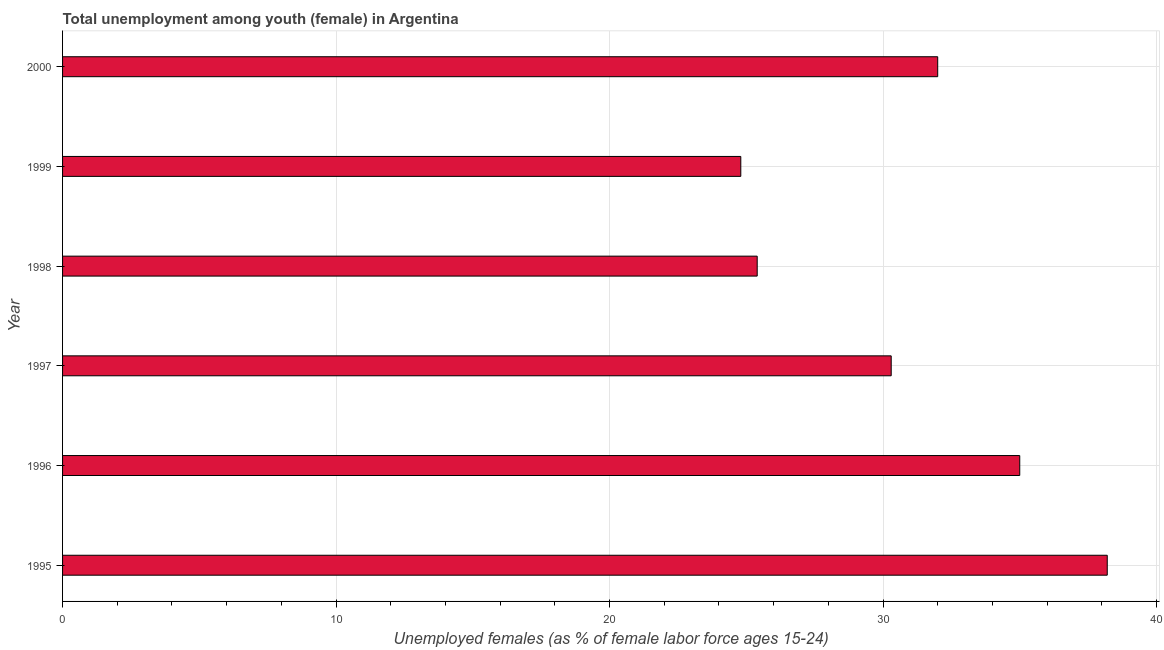Does the graph contain any zero values?
Give a very brief answer. No. What is the title of the graph?
Make the answer very short. Total unemployment among youth (female) in Argentina. What is the label or title of the X-axis?
Keep it short and to the point. Unemployed females (as % of female labor force ages 15-24). What is the unemployed female youth population in 1998?
Provide a succinct answer. 25.4. Across all years, what is the maximum unemployed female youth population?
Your answer should be very brief. 38.2. Across all years, what is the minimum unemployed female youth population?
Your answer should be very brief. 24.8. In which year was the unemployed female youth population maximum?
Offer a terse response. 1995. What is the sum of the unemployed female youth population?
Make the answer very short. 185.7. What is the average unemployed female youth population per year?
Give a very brief answer. 30.95. What is the median unemployed female youth population?
Your answer should be compact. 31.15. What is the ratio of the unemployed female youth population in 1997 to that in 1999?
Your response must be concise. 1.22. Is the unemployed female youth population in 1995 less than that in 1997?
Give a very brief answer. No. In how many years, is the unemployed female youth population greater than the average unemployed female youth population taken over all years?
Ensure brevity in your answer.  3. Are all the bars in the graph horizontal?
Give a very brief answer. Yes. How many years are there in the graph?
Your answer should be compact. 6. What is the difference between two consecutive major ticks on the X-axis?
Provide a succinct answer. 10. What is the Unemployed females (as % of female labor force ages 15-24) of 1995?
Ensure brevity in your answer.  38.2. What is the Unemployed females (as % of female labor force ages 15-24) in 1996?
Keep it short and to the point. 35. What is the Unemployed females (as % of female labor force ages 15-24) of 1997?
Keep it short and to the point. 30.3. What is the Unemployed females (as % of female labor force ages 15-24) in 1998?
Give a very brief answer. 25.4. What is the Unemployed females (as % of female labor force ages 15-24) of 1999?
Offer a terse response. 24.8. What is the difference between the Unemployed females (as % of female labor force ages 15-24) in 1995 and 1999?
Your answer should be compact. 13.4. What is the difference between the Unemployed females (as % of female labor force ages 15-24) in 1995 and 2000?
Keep it short and to the point. 6.2. What is the difference between the Unemployed females (as % of female labor force ages 15-24) in 1996 and 1997?
Your answer should be very brief. 4.7. What is the difference between the Unemployed females (as % of female labor force ages 15-24) in 1996 and 1999?
Offer a terse response. 10.2. What is the difference between the Unemployed females (as % of female labor force ages 15-24) in 1996 and 2000?
Provide a short and direct response. 3. What is the difference between the Unemployed females (as % of female labor force ages 15-24) in 1997 and 1998?
Provide a succinct answer. 4.9. What is the ratio of the Unemployed females (as % of female labor force ages 15-24) in 1995 to that in 1996?
Offer a very short reply. 1.09. What is the ratio of the Unemployed females (as % of female labor force ages 15-24) in 1995 to that in 1997?
Ensure brevity in your answer.  1.26. What is the ratio of the Unemployed females (as % of female labor force ages 15-24) in 1995 to that in 1998?
Offer a very short reply. 1.5. What is the ratio of the Unemployed females (as % of female labor force ages 15-24) in 1995 to that in 1999?
Ensure brevity in your answer.  1.54. What is the ratio of the Unemployed females (as % of female labor force ages 15-24) in 1995 to that in 2000?
Ensure brevity in your answer.  1.19. What is the ratio of the Unemployed females (as % of female labor force ages 15-24) in 1996 to that in 1997?
Provide a succinct answer. 1.16. What is the ratio of the Unemployed females (as % of female labor force ages 15-24) in 1996 to that in 1998?
Offer a very short reply. 1.38. What is the ratio of the Unemployed females (as % of female labor force ages 15-24) in 1996 to that in 1999?
Provide a short and direct response. 1.41. What is the ratio of the Unemployed females (as % of female labor force ages 15-24) in 1996 to that in 2000?
Make the answer very short. 1.09. What is the ratio of the Unemployed females (as % of female labor force ages 15-24) in 1997 to that in 1998?
Provide a short and direct response. 1.19. What is the ratio of the Unemployed females (as % of female labor force ages 15-24) in 1997 to that in 1999?
Offer a very short reply. 1.22. What is the ratio of the Unemployed females (as % of female labor force ages 15-24) in 1997 to that in 2000?
Make the answer very short. 0.95. What is the ratio of the Unemployed females (as % of female labor force ages 15-24) in 1998 to that in 1999?
Provide a succinct answer. 1.02. What is the ratio of the Unemployed females (as % of female labor force ages 15-24) in 1998 to that in 2000?
Keep it short and to the point. 0.79. What is the ratio of the Unemployed females (as % of female labor force ages 15-24) in 1999 to that in 2000?
Keep it short and to the point. 0.78. 